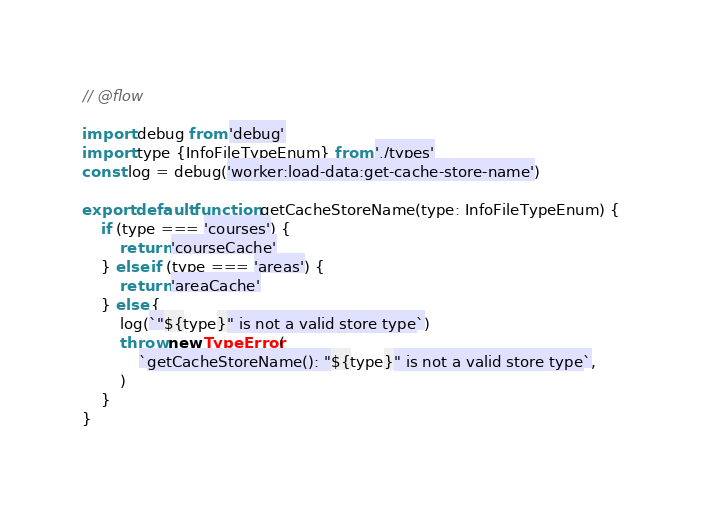<code> <loc_0><loc_0><loc_500><loc_500><_JavaScript_>// @flow

import debug from 'debug'
import type {InfoFileTypeEnum} from './types'
const log = debug('worker:load-data:get-cache-store-name')

export default function getCacheStoreName(type: InfoFileTypeEnum) {
	if (type === 'courses') {
		return 'courseCache'
	} else if (type === 'areas') {
		return 'areaCache'
	} else {
		log(`"${type}" is not a valid store type`)
		throw new TypeError(
			`getCacheStoreName(): "${type}" is not a valid store type`,
		)
	}
}
</code> 